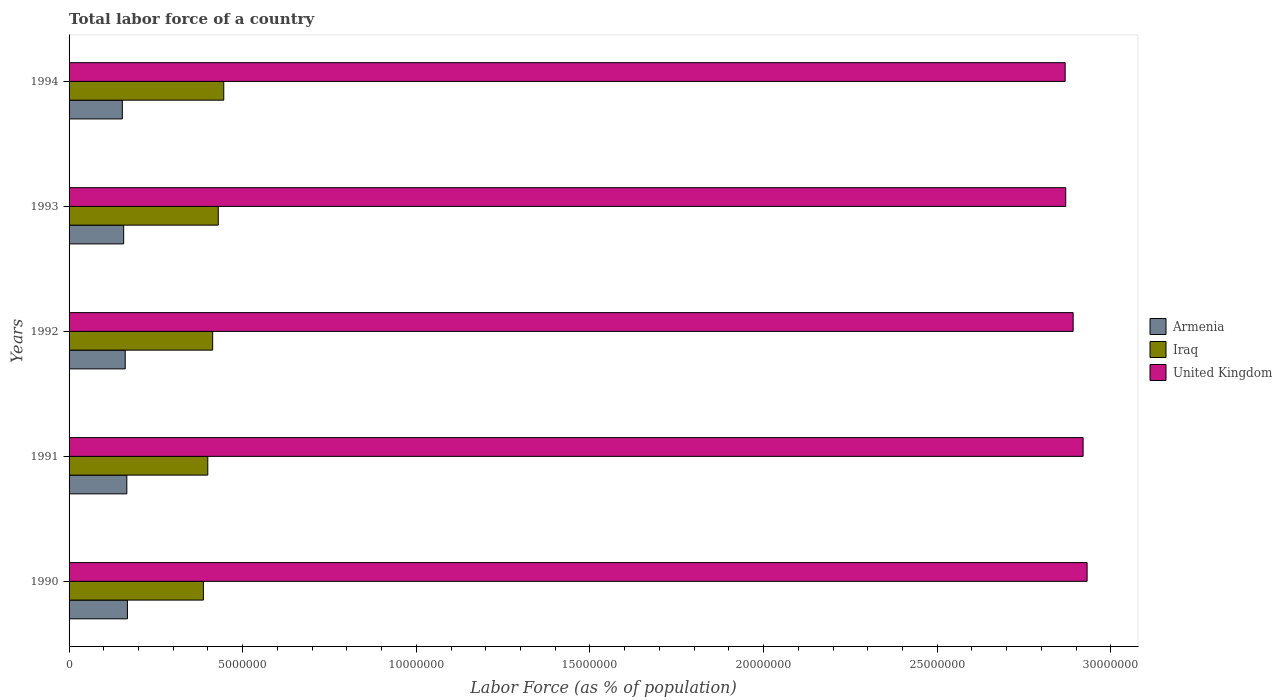How many different coloured bars are there?
Provide a short and direct response. 3. How many groups of bars are there?
Give a very brief answer. 5. How many bars are there on the 3rd tick from the bottom?
Offer a very short reply. 3. What is the label of the 2nd group of bars from the top?
Provide a succinct answer. 1993. In how many cases, is the number of bars for a given year not equal to the number of legend labels?
Your answer should be compact. 0. What is the percentage of labor force in Armenia in 1993?
Your response must be concise. 1.57e+06. Across all years, what is the maximum percentage of labor force in Armenia?
Your answer should be very brief. 1.68e+06. Across all years, what is the minimum percentage of labor force in United Kingdom?
Your answer should be compact. 2.87e+07. In which year was the percentage of labor force in Iraq minimum?
Give a very brief answer. 1990. What is the total percentage of labor force in United Kingdom in the graph?
Make the answer very short. 1.45e+08. What is the difference between the percentage of labor force in Iraq in 1992 and that in 1994?
Ensure brevity in your answer.  -3.20e+05. What is the difference between the percentage of labor force in Armenia in 1992 and the percentage of labor force in Iraq in 1993?
Keep it short and to the point. -2.68e+06. What is the average percentage of labor force in Iraq per year?
Keep it short and to the point. 4.15e+06. In the year 1992, what is the difference between the percentage of labor force in Iraq and percentage of labor force in Armenia?
Ensure brevity in your answer.  2.52e+06. In how many years, is the percentage of labor force in United Kingdom greater than 6000000 %?
Provide a short and direct response. 5. What is the ratio of the percentage of labor force in Iraq in 1990 to that in 1991?
Ensure brevity in your answer.  0.97. What is the difference between the highest and the second highest percentage of labor force in Iraq?
Give a very brief answer. 1.58e+05. What is the difference between the highest and the lowest percentage of labor force in Armenia?
Provide a succinct answer. 1.47e+05. What does the 3rd bar from the top in 1993 represents?
Offer a very short reply. Armenia. What does the 1st bar from the bottom in 1992 represents?
Provide a short and direct response. Armenia. How many bars are there?
Your answer should be compact. 15. Are all the bars in the graph horizontal?
Give a very brief answer. Yes. What is the difference between two consecutive major ticks on the X-axis?
Provide a succinct answer. 5.00e+06. Are the values on the major ticks of X-axis written in scientific E-notation?
Your response must be concise. No. Does the graph contain grids?
Offer a terse response. No. Where does the legend appear in the graph?
Offer a very short reply. Center right. How are the legend labels stacked?
Your response must be concise. Vertical. What is the title of the graph?
Offer a terse response. Total labor force of a country. Does "Channel Islands" appear as one of the legend labels in the graph?
Offer a very short reply. No. What is the label or title of the X-axis?
Your answer should be very brief. Labor Force (as % of population). What is the label or title of the Y-axis?
Your answer should be compact. Years. What is the Labor Force (as % of population) in Armenia in 1990?
Make the answer very short. 1.68e+06. What is the Labor Force (as % of population) of Iraq in 1990?
Make the answer very short. 3.87e+06. What is the Labor Force (as % of population) in United Kingdom in 1990?
Make the answer very short. 2.93e+07. What is the Labor Force (as % of population) of Armenia in 1991?
Provide a succinct answer. 1.66e+06. What is the Labor Force (as % of population) of Iraq in 1991?
Give a very brief answer. 4.00e+06. What is the Labor Force (as % of population) of United Kingdom in 1991?
Offer a terse response. 2.92e+07. What is the Labor Force (as % of population) in Armenia in 1992?
Keep it short and to the point. 1.62e+06. What is the Labor Force (as % of population) in Iraq in 1992?
Your answer should be compact. 4.14e+06. What is the Labor Force (as % of population) in United Kingdom in 1992?
Offer a terse response. 2.89e+07. What is the Labor Force (as % of population) in Armenia in 1993?
Offer a terse response. 1.57e+06. What is the Labor Force (as % of population) of Iraq in 1993?
Your answer should be very brief. 4.30e+06. What is the Labor Force (as % of population) of United Kingdom in 1993?
Your answer should be compact. 2.87e+07. What is the Labor Force (as % of population) in Armenia in 1994?
Offer a terse response. 1.53e+06. What is the Labor Force (as % of population) in Iraq in 1994?
Make the answer very short. 4.45e+06. What is the Labor Force (as % of population) in United Kingdom in 1994?
Your response must be concise. 2.87e+07. Across all years, what is the maximum Labor Force (as % of population) in Armenia?
Your answer should be compact. 1.68e+06. Across all years, what is the maximum Labor Force (as % of population) of Iraq?
Provide a succinct answer. 4.45e+06. Across all years, what is the maximum Labor Force (as % of population) in United Kingdom?
Give a very brief answer. 2.93e+07. Across all years, what is the minimum Labor Force (as % of population) of Armenia?
Ensure brevity in your answer.  1.53e+06. Across all years, what is the minimum Labor Force (as % of population) of Iraq?
Ensure brevity in your answer.  3.87e+06. Across all years, what is the minimum Labor Force (as % of population) in United Kingdom?
Offer a very short reply. 2.87e+07. What is the total Labor Force (as % of population) in Armenia in the graph?
Make the answer very short. 8.07e+06. What is the total Labor Force (as % of population) of Iraq in the graph?
Provide a succinct answer. 2.07e+07. What is the total Labor Force (as % of population) of United Kingdom in the graph?
Provide a succinct answer. 1.45e+08. What is the difference between the Labor Force (as % of population) of Armenia in 1990 and that in 1991?
Offer a very short reply. 1.74e+04. What is the difference between the Labor Force (as % of population) of Iraq in 1990 and that in 1991?
Offer a terse response. -1.27e+05. What is the difference between the Labor Force (as % of population) of United Kingdom in 1990 and that in 1991?
Your response must be concise. 1.15e+05. What is the difference between the Labor Force (as % of population) in Armenia in 1990 and that in 1992?
Your response must be concise. 6.37e+04. What is the difference between the Labor Force (as % of population) of Iraq in 1990 and that in 1992?
Your answer should be compact. -2.67e+05. What is the difference between the Labor Force (as % of population) of United Kingdom in 1990 and that in 1992?
Ensure brevity in your answer.  4.02e+05. What is the difference between the Labor Force (as % of population) of Armenia in 1990 and that in 1993?
Your response must be concise. 1.09e+05. What is the difference between the Labor Force (as % of population) in Iraq in 1990 and that in 1993?
Keep it short and to the point. -4.28e+05. What is the difference between the Labor Force (as % of population) of United Kingdom in 1990 and that in 1993?
Your answer should be compact. 6.15e+05. What is the difference between the Labor Force (as % of population) in Armenia in 1990 and that in 1994?
Offer a very short reply. 1.47e+05. What is the difference between the Labor Force (as % of population) in Iraq in 1990 and that in 1994?
Make the answer very short. -5.86e+05. What is the difference between the Labor Force (as % of population) in United Kingdom in 1990 and that in 1994?
Your answer should be compact. 6.32e+05. What is the difference between the Labor Force (as % of population) in Armenia in 1991 and that in 1992?
Your response must be concise. 4.64e+04. What is the difference between the Labor Force (as % of population) in Iraq in 1991 and that in 1992?
Offer a very short reply. -1.40e+05. What is the difference between the Labor Force (as % of population) of United Kingdom in 1991 and that in 1992?
Give a very brief answer. 2.87e+05. What is the difference between the Labor Force (as % of population) in Armenia in 1991 and that in 1993?
Your response must be concise. 9.13e+04. What is the difference between the Labor Force (as % of population) in Iraq in 1991 and that in 1993?
Give a very brief answer. -3.01e+05. What is the difference between the Labor Force (as % of population) in United Kingdom in 1991 and that in 1993?
Give a very brief answer. 5.00e+05. What is the difference between the Labor Force (as % of population) in Armenia in 1991 and that in 1994?
Offer a terse response. 1.30e+05. What is the difference between the Labor Force (as % of population) in Iraq in 1991 and that in 1994?
Ensure brevity in your answer.  -4.60e+05. What is the difference between the Labor Force (as % of population) of United Kingdom in 1991 and that in 1994?
Make the answer very short. 5.17e+05. What is the difference between the Labor Force (as % of population) in Armenia in 1992 and that in 1993?
Offer a very short reply. 4.49e+04. What is the difference between the Labor Force (as % of population) in Iraq in 1992 and that in 1993?
Your response must be concise. -1.61e+05. What is the difference between the Labor Force (as % of population) in United Kingdom in 1992 and that in 1993?
Ensure brevity in your answer.  2.14e+05. What is the difference between the Labor Force (as % of population) of Armenia in 1992 and that in 1994?
Your answer should be very brief. 8.34e+04. What is the difference between the Labor Force (as % of population) in Iraq in 1992 and that in 1994?
Offer a very short reply. -3.20e+05. What is the difference between the Labor Force (as % of population) in United Kingdom in 1992 and that in 1994?
Make the answer very short. 2.30e+05. What is the difference between the Labor Force (as % of population) in Armenia in 1993 and that in 1994?
Provide a succinct answer. 3.85e+04. What is the difference between the Labor Force (as % of population) in Iraq in 1993 and that in 1994?
Ensure brevity in your answer.  -1.58e+05. What is the difference between the Labor Force (as % of population) in United Kingdom in 1993 and that in 1994?
Your answer should be compact. 1.66e+04. What is the difference between the Labor Force (as % of population) in Armenia in 1990 and the Labor Force (as % of population) in Iraq in 1991?
Provide a short and direct response. -2.31e+06. What is the difference between the Labor Force (as % of population) of Armenia in 1990 and the Labor Force (as % of population) of United Kingdom in 1991?
Offer a very short reply. -2.75e+07. What is the difference between the Labor Force (as % of population) in Iraq in 1990 and the Labor Force (as % of population) in United Kingdom in 1991?
Your answer should be very brief. -2.53e+07. What is the difference between the Labor Force (as % of population) in Armenia in 1990 and the Labor Force (as % of population) in Iraq in 1992?
Offer a terse response. -2.45e+06. What is the difference between the Labor Force (as % of population) in Armenia in 1990 and the Labor Force (as % of population) in United Kingdom in 1992?
Your response must be concise. -2.72e+07. What is the difference between the Labor Force (as % of population) in Iraq in 1990 and the Labor Force (as % of population) in United Kingdom in 1992?
Ensure brevity in your answer.  -2.50e+07. What is the difference between the Labor Force (as % of population) of Armenia in 1990 and the Labor Force (as % of population) of Iraq in 1993?
Your response must be concise. -2.62e+06. What is the difference between the Labor Force (as % of population) of Armenia in 1990 and the Labor Force (as % of population) of United Kingdom in 1993?
Your answer should be very brief. -2.70e+07. What is the difference between the Labor Force (as % of population) in Iraq in 1990 and the Labor Force (as % of population) in United Kingdom in 1993?
Make the answer very short. -2.48e+07. What is the difference between the Labor Force (as % of population) of Armenia in 1990 and the Labor Force (as % of population) of Iraq in 1994?
Keep it short and to the point. -2.77e+06. What is the difference between the Labor Force (as % of population) of Armenia in 1990 and the Labor Force (as % of population) of United Kingdom in 1994?
Offer a terse response. -2.70e+07. What is the difference between the Labor Force (as % of population) in Iraq in 1990 and the Labor Force (as % of population) in United Kingdom in 1994?
Provide a short and direct response. -2.48e+07. What is the difference between the Labor Force (as % of population) in Armenia in 1991 and the Labor Force (as % of population) in Iraq in 1992?
Offer a terse response. -2.47e+06. What is the difference between the Labor Force (as % of population) in Armenia in 1991 and the Labor Force (as % of population) in United Kingdom in 1992?
Ensure brevity in your answer.  -2.73e+07. What is the difference between the Labor Force (as % of population) in Iraq in 1991 and the Labor Force (as % of population) in United Kingdom in 1992?
Your response must be concise. -2.49e+07. What is the difference between the Labor Force (as % of population) in Armenia in 1991 and the Labor Force (as % of population) in Iraq in 1993?
Your answer should be compact. -2.63e+06. What is the difference between the Labor Force (as % of population) of Armenia in 1991 and the Labor Force (as % of population) of United Kingdom in 1993?
Provide a succinct answer. -2.70e+07. What is the difference between the Labor Force (as % of population) in Iraq in 1991 and the Labor Force (as % of population) in United Kingdom in 1993?
Keep it short and to the point. -2.47e+07. What is the difference between the Labor Force (as % of population) in Armenia in 1991 and the Labor Force (as % of population) in Iraq in 1994?
Offer a very short reply. -2.79e+06. What is the difference between the Labor Force (as % of population) of Armenia in 1991 and the Labor Force (as % of population) of United Kingdom in 1994?
Provide a succinct answer. -2.70e+07. What is the difference between the Labor Force (as % of population) in Iraq in 1991 and the Labor Force (as % of population) in United Kingdom in 1994?
Ensure brevity in your answer.  -2.47e+07. What is the difference between the Labor Force (as % of population) in Armenia in 1992 and the Labor Force (as % of population) in Iraq in 1993?
Your answer should be very brief. -2.68e+06. What is the difference between the Labor Force (as % of population) of Armenia in 1992 and the Labor Force (as % of population) of United Kingdom in 1993?
Ensure brevity in your answer.  -2.71e+07. What is the difference between the Labor Force (as % of population) in Iraq in 1992 and the Labor Force (as % of population) in United Kingdom in 1993?
Provide a short and direct response. -2.46e+07. What is the difference between the Labor Force (as % of population) in Armenia in 1992 and the Labor Force (as % of population) in Iraq in 1994?
Provide a succinct answer. -2.84e+06. What is the difference between the Labor Force (as % of population) in Armenia in 1992 and the Labor Force (as % of population) in United Kingdom in 1994?
Your answer should be compact. -2.71e+07. What is the difference between the Labor Force (as % of population) in Iraq in 1992 and the Labor Force (as % of population) in United Kingdom in 1994?
Your answer should be compact. -2.45e+07. What is the difference between the Labor Force (as % of population) of Armenia in 1993 and the Labor Force (as % of population) of Iraq in 1994?
Your response must be concise. -2.88e+06. What is the difference between the Labor Force (as % of population) of Armenia in 1993 and the Labor Force (as % of population) of United Kingdom in 1994?
Offer a terse response. -2.71e+07. What is the difference between the Labor Force (as % of population) of Iraq in 1993 and the Labor Force (as % of population) of United Kingdom in 1994?
Ensure brevity in your answer.  -2.44e+07. What is the average Labor Force (as % of population) in Armenia per year?
Ensure brevity in your answer.  1.61e+06. What is the average Labor Force (as % of population) of Iraq per year?
Your answer should be compact. 4.15e+06. What is the average Labor Force (as % of population) of United Kingdom per year?
Offer a terse response. 2.90e+07. In the year 1990, what is the difference between the Labor Force (as % of population) of Armenia and Labor Force (as % of population) of Iraq?
Provide a short and direct response. -2.19e+06. In the year 1990, what is the difference between the Labor Force (as % of population) of Armenia and Labor Force (as % of population) of United Kingdom?
Give a very brief answer. -2.76e+07. In the year 1990, what is the difference between the Labor Force (as % of population) in Iraq and Labor Force (as % of population) in United Kingdom?
Ensure brevity in your answer.  -2.54e+07. In the year 1991, what is the difference between the Labor Force (as % of population) in Armenia and Labor Force (as % of population) in Iraq?
Offer a terse response. -2.33e+06. In the year 1991, what is the difference between the Labor Force (as % of population) in Armenia and Labor Force (as % of population) in United Kingdom?
Provide a short and direct response. -2.75e+07. In the year 1991, what is the difference between the Labor Force (as % of population) of Iraq and Labor Force (as % of population) of United Kingdom?
Give a very brief answer. -2.52e+07. In the year 1992, what is the difference between the Labor Force (as % of population) in Armenia and Labor Force (as % of population) in Iraq?
Give a very brief answer. -2.52e+06. In the year 1992, what is the difference between the Labor Force (as % of population) of Armenia and Labor Force (as % of population) of United Kingdom?
Provide a succinct answer. -2.73e+07. In the year 1992, what is the difference between the Labor Force (as % of population) in Iraq and Labor Force (as % of population) in United Kingdom?
Your answer should be very brief. -2.48e+07. In the year 1993, what is the difference between the Labor Force (as % of population) in Armenia and Labor Force (as % of population) in Iraq?
Make the answer very short. -2.72e+06. In the year 1993, what is the difference between the Labor Force (as % of population) in Armenia and Labor Force (as % of population) in United Kingdom?
Provide a short and direct response. -2.71e+07. In the year 1993, what is the difference between the Labor Force (as % of population) of Iraq and Labor Force (as % of population) of United Kingdom?
Offer a terse response. -2.44e+07. In the year 1994, what is the difference between the Labor Force (as % of population) in Armenia and Labor Force (as % of population) in Iraq?
Keep it short and to the point. -2.92e+06. In the year 1994, what is the difference between the Labor Force (as % of population) in Armenia and Labor Force (as % of population) in United Kingdom?
Offer a terse response. -2.72e+07. In the year 1994, what is the difference between the Labor Force (as % of population) of Iraq and Labor Force (as % of population) of United Kingdom?
Your response must be concise. -2.42e+07. What is the ratio of the Labor Force (as % of population) in Armenia in 1990 to that in 1991?
Offer a very short reply. 1.01. What is the ratio of the Labor Force (as % of population) of Iraq in 1990 to that in 1991?
Ensure brevity in your answer.  0.97. What is the ratio of the Labor Force (as % of population) of Armenia in 1990 to that in 1992?
Ensure brevity in your answer.  1.04. What is the ratio of the Labor Force (as % of population) of Iraq in 1990 to that in 1992?
Your answer should be compact. 0.94. What is the ratio of the Labor Force (as % of population) in United Kingdom in 1990 to that in 1992?
Your answer should be very brief. 1.01. What is the ratio of the Labor Force (as % of population) of Armenia in 1990 to that in 1993?
Give a very brief answer. 1.07. What is the ratio of the Labor Force (as % of population) in Iraq in 1990 to that in 1993?
Your answer should be very brief. 0.9. What is the ratio of the Labor Force (as % of population) of United Kingdom in 1990 to that in 1993?
Provide a succinct answer. 1.02. What is the ratio of the Labor Force (as % of population) in Armenia in 1990 to that in 1994?
Offer a very short reply. 1.1. What is the ratio of the Labor Force (as % of population) of Iraq in 1990 to that in 1994?
Your answer should be compact. 0.87. What is the ratio of the Labor Force (as % of population) in United Kingdom in 1990 to that in 1994?
Make the answer very short. 1.02. What is the ratio of the Labor Force (as % of population) in Armenia in 1991 to that in 1992?
Give a very brief answer. 1.03. What is the ratio of the Labor Force (as % of population) of Iraq in 1991 to that in 1992?
Provide a succinct answer. 0.97. What is the ratio of the Labor Force (as % of population) in United Kingdom in 1991 to that in 1992?
Keep it short and to the point. 1.01. What is the ratio of the Labor Force (as % of population) in Armenia in 1991 to that in 1993?
Offer a very short reply. 1.06. What is the ratio of the Labor Force (as % of population) in Iraq in 1991 to that in 1993?
Ensure brevity in your answer.  0.93. What is the ratio of the Labor Force (as % of population) in United Kingdom in 1991 to that in 1993?
Provide a succinct answer. 1.02. What is the ratio of the Labor Force (as % of population) of Armenia in 1991 to that in 1994?
Keep it short and to the point. 1.08. What is the ratio of the Labor Force (as % of population) in Iraq in 1991 to that in 1994?
Your answer should be compact. 0.9. What is the ratio of the Labor Force (as % of population) of Armenia in 1992 to that in 1993?
Provide a short and direct response. 1.03. What is the ratio of the Labor Force (as % of population) of Iraq in 1992 to that in 1993?
Offer a terse response. 0.96. What is the ratio of the Labor Force (as % of population) of United Kingdom in 1992 to that in 1993?
Your answer should be compact. 1.01. What is the ratio of the Labor Force (as % of population) in Armenia in 1992 to that in 1994?
Your answer should be compact. 1.05. What is the ratio of the Labor Force (as % of population) of Iraq in 1992 to that in 1994?
Offer a terse response. 0.93. What is the ratio of the Labor Force (as % of population) of Armenia in 1993 to that in 1994?
Keep it short and to the point. 1.03. What is the ratio of the Labor Force (as % of population) in Iraq in 1993 to that in 1994?
Provide a succinct answer. 0.96. What is the difference between the highest and the second highest Labor Force (as % of population) of Armenia?
Keep it short and to the point. 1.74e+04. What is the difference between the highest and the second highest Labor Force (as % of population) in Iraq?
Provide a succinct answer. 1.58e+05. What is the difference between the highest and the second highest Labor Force (as % of population) in United Kingdom?
Offer a terse response. 1.15e+05. What is the difference between the highest and the lowest Labor Force (as % of population) of Armenia?
Offer a very short reply. 1.47e+05. What is the difference between the highest and the lowest Labor Force (as % of population) in Iraq?
Offer a very short reply. 5.86e+05. What is the difference between the highest and the lowest Labor Force (as % of population) in United Kingdom?
Offer a very short reply. 6.32e+05. 